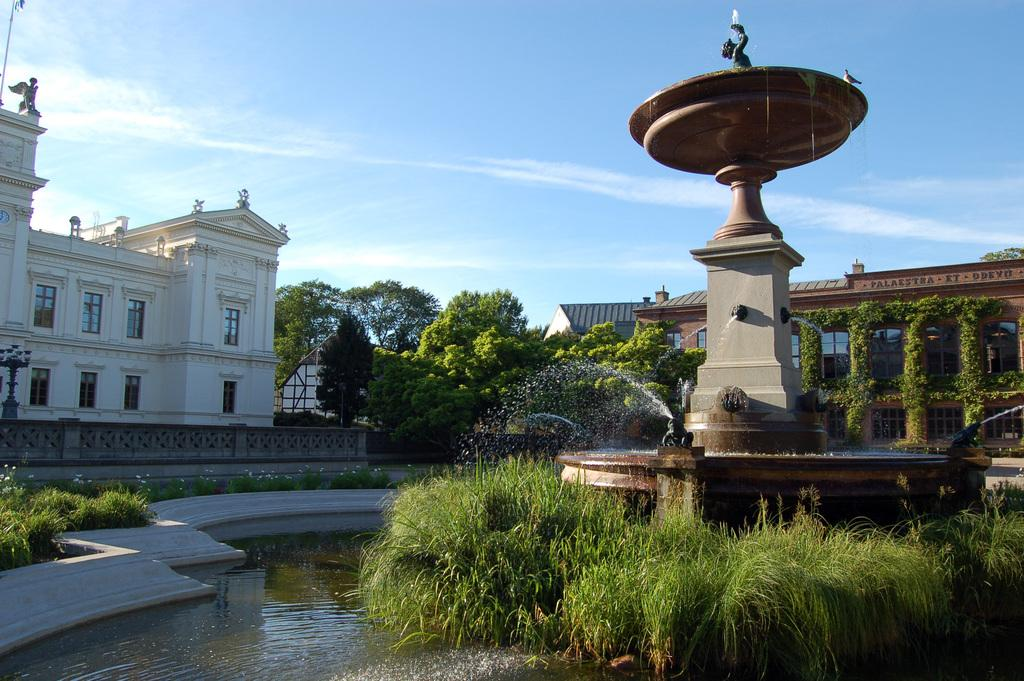What is the main feature in the image? There is a fountain present in the image. What else can be seen near the fountain? There is a statue in the image. What type of vegetation is visible in the image? Plants and trees are visible in the image. Can you describe the water feature in the image? Water is present in the image, as part of the fountain. What type of structures are visible in the image? Buildings with windows are present in the image. What else is present in the image? There are some objects in the image. What can be seen in the background of the image? The sky is visible in the background of the image. What type of flesh can be seen on the governor's face in the image? There is no governor or flesh present in the image. 